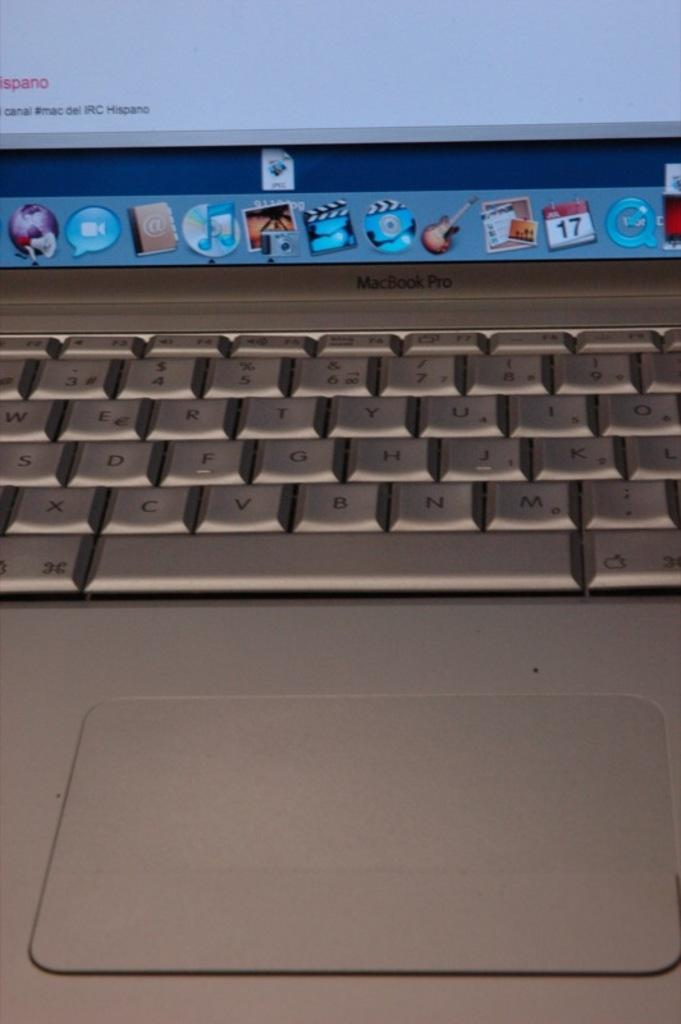<image>
Write a terse but informative summary of the picture. Portrait photo of a macbook pro, containing mostly the keyboard and only a fraction of the screen. 